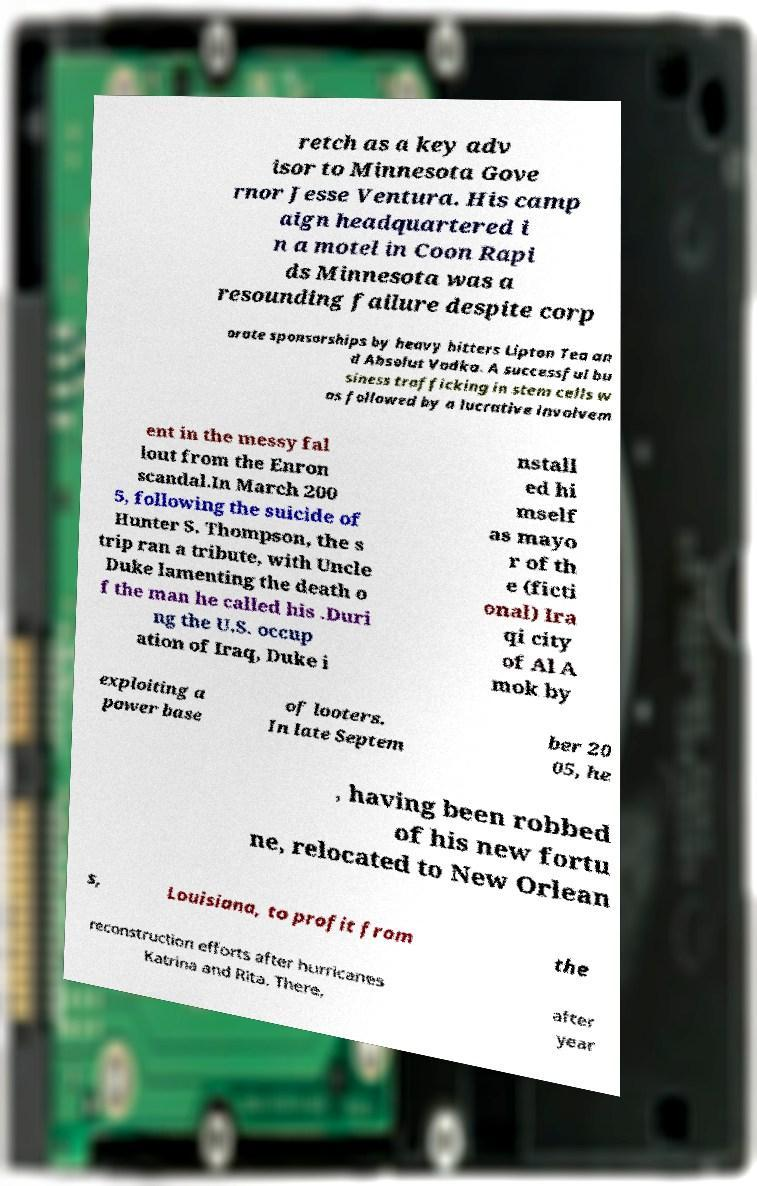There's text embedded in this image that I need extracted. Can you transcribe it verbatim? retch as a key adv isor to Minnesota Gove rnor Jesse Ventura. His camp aign headquartered i n a motel in Coon Rapi ds Minnesota was a resounding failure despite corp orate sponsorships by heavy hitters Lipton Tea an d Absolut Vodka. A successful bu siness trafficking in stem cells w as followed by a lucrative involvem ent in the messy fal lout from the Enron scandal.In March 200 5, following the suicide of Hunter S. Thompson, the s trip ran a tribute, with Uncle Duke lamenting the death o f the man he called his .Duri ng the U.S. occup ation of Iraq, Duke i nstall ed hi mself as mayo r of th e (ficti onal) Ira qi city of Al A mok by exploiting a power base of looters. In late Septem ber 20 05, he , having been robbed of his new fortu ne, relocated to New Orlean s, Louisiana, to profit from the reconstruction efforts after hurricanes Katrina and Rita. There, after year 